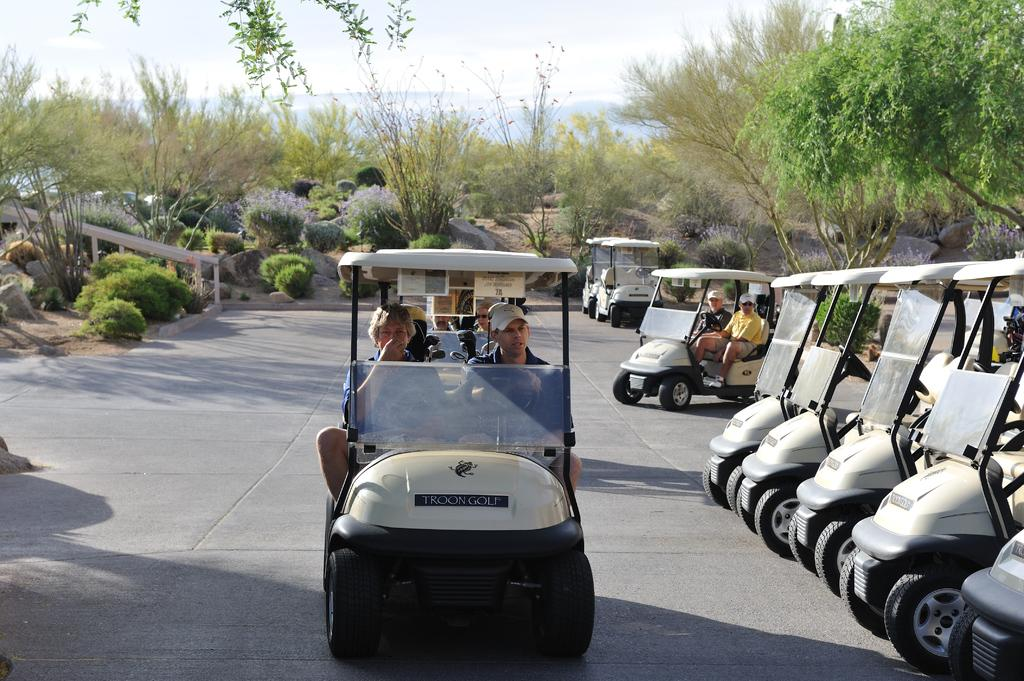What types of objects are present in the image? There are vehicles and persons in the image. Can you describe the setting of the image? The image features trees in the background and the sky visible in the background. How many elements can be seen in the background? There are two elements in the background: trees and the sky. What color is the hydrant in the image? There is no hydrant present in the image. How many docks can be seen in the image? There are no docks present in the image. 